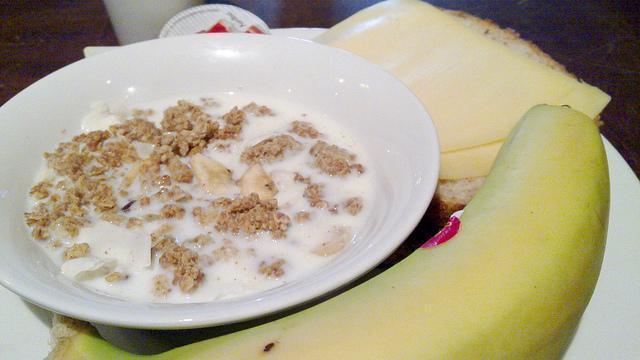Is the statement "The banana is left of the sandwich." accurate regarding the image?
Answer yes or no. No. Is "The bowl contains the sandwich." an appropriate description for the image?
Answer yes or no. No. Does the caption "The sandwich contains the banana." correctly depict the image?
Answer yes or no. No. Does the image validate the caption "The sandwich is in front of the banana."?
Answer yes or no. No. Does the caption "The banana is in the bowl." correctly depict the image?
Answer yes or no. No. Is the statement "The banana is part of the sandwich." accurate regarding the image?
Answer yes or no. No. 